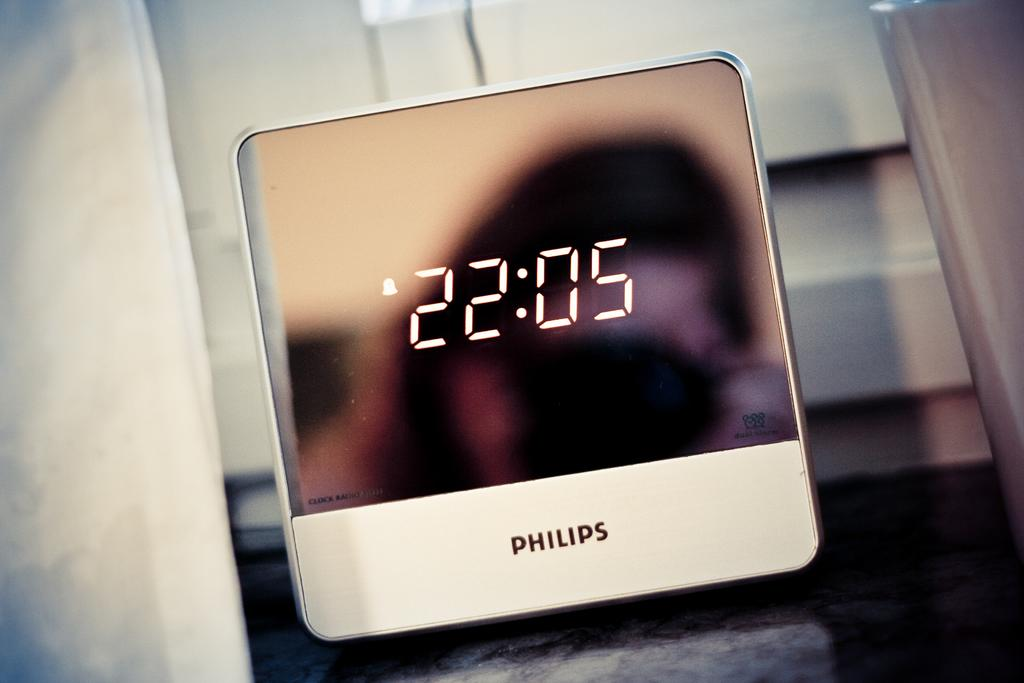<image>
Present a compact description of the photo's key features. A sleek white Philips alarm clock shows the time 22:05. 